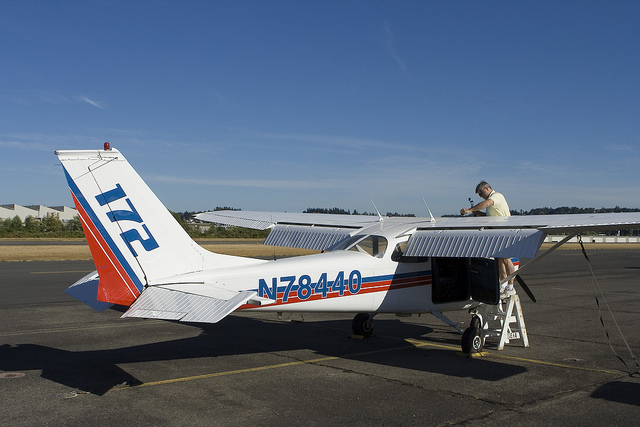Please identify all text content in this image. 172 N78440 